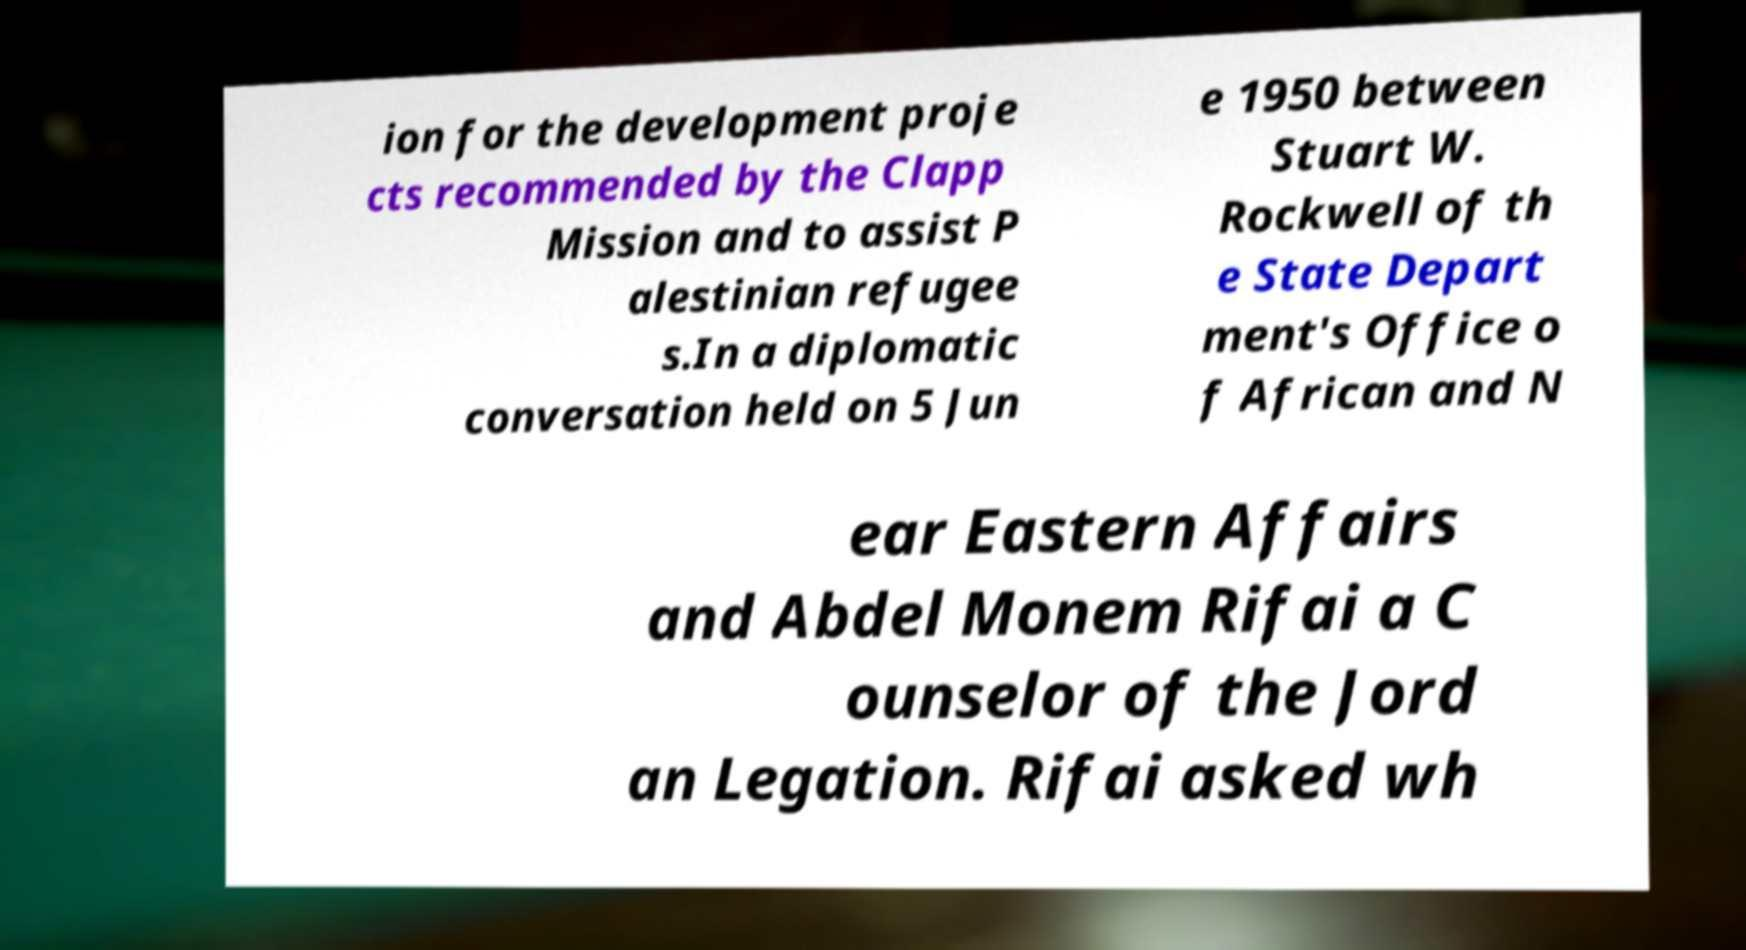What messages or text are displayed in this image? I need them in a readable, typed format. ion for the development proje cts recommended by the Clapp Mission and to assist P alestinian refugee s.In a diplomatic conversation held on 5 Jun e 1950 between Stuart W. Rockwell of th e State Depart ment's Office o f African and N ear Eastern Affairs and Abdel Monem Rifai a C ounselor of the Jord an Legation. Rifai asked wh 